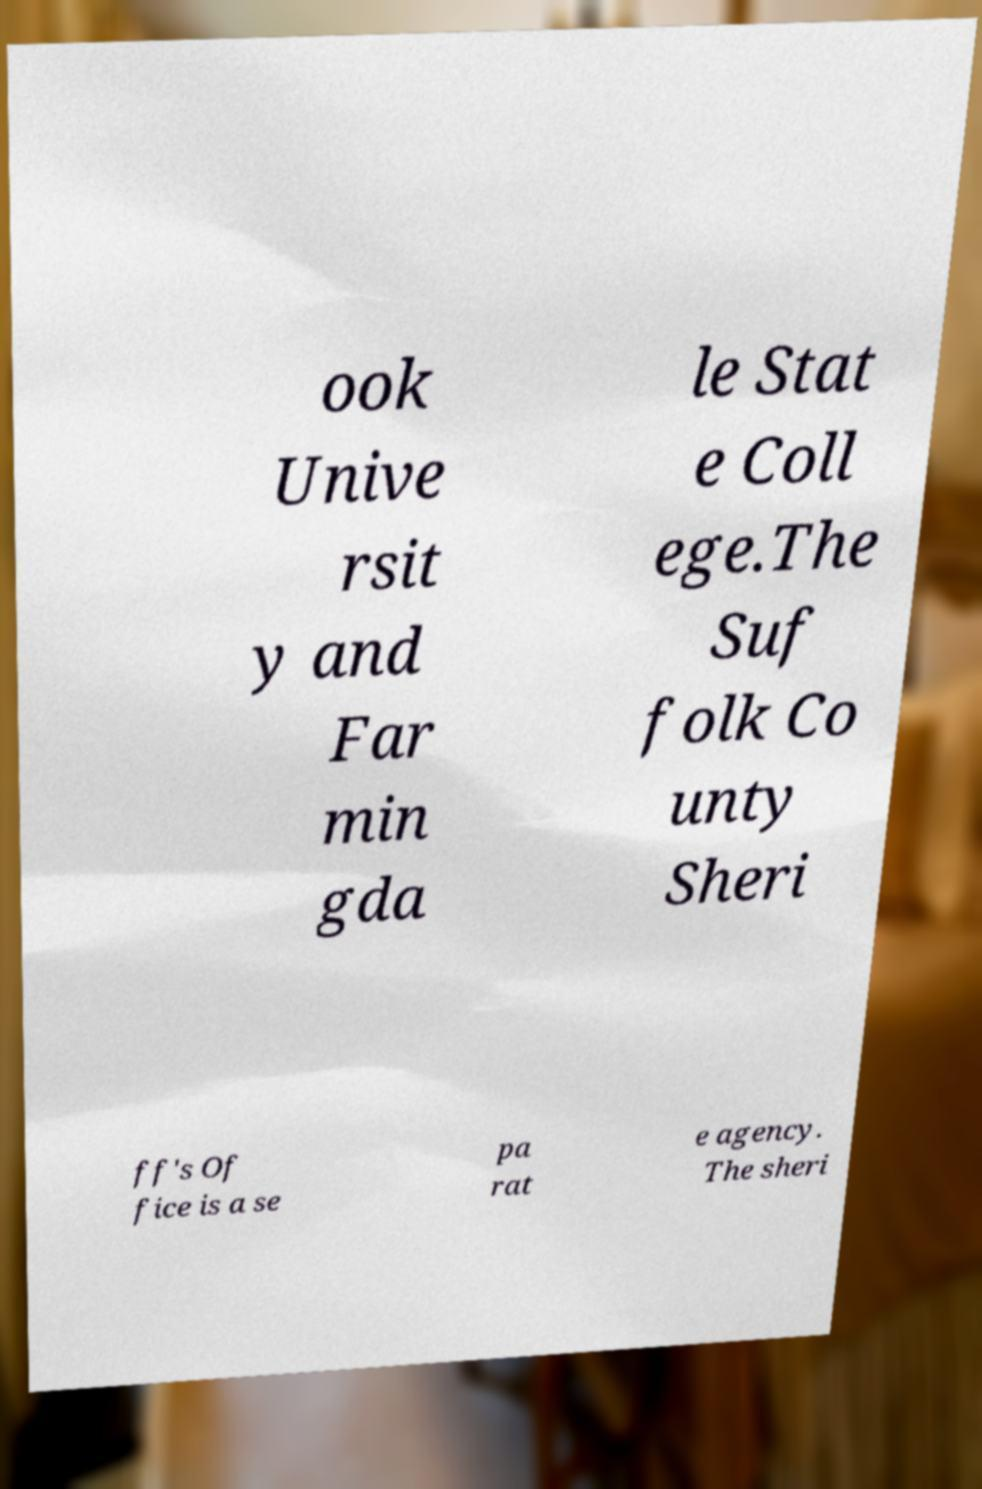There's text embedded in this image that I need extracted. Can you transcribe it verbatim? ook Unive rsit y and Far min gda le Stat e Coll ege.The Suf folk Co unty Sheri ff's Of fice is a se pa rat e agency. The sheri 